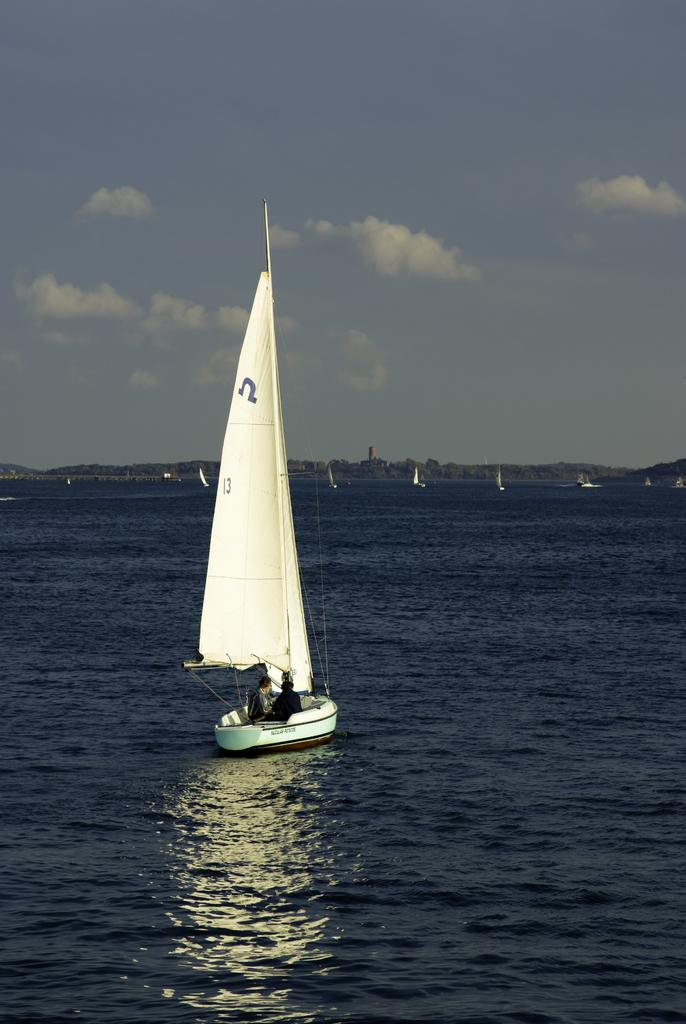What is happening in the foreground of the image? There is a boat sailing on the water in the foreground. How many people are in the boat? There are two people in the boat. What can be seen in the background of the image? In the background, there are other boats visible. What type of toys are being used to power the boat in the image? There are no toys present in the image, and the boat is not powered by any toys. 